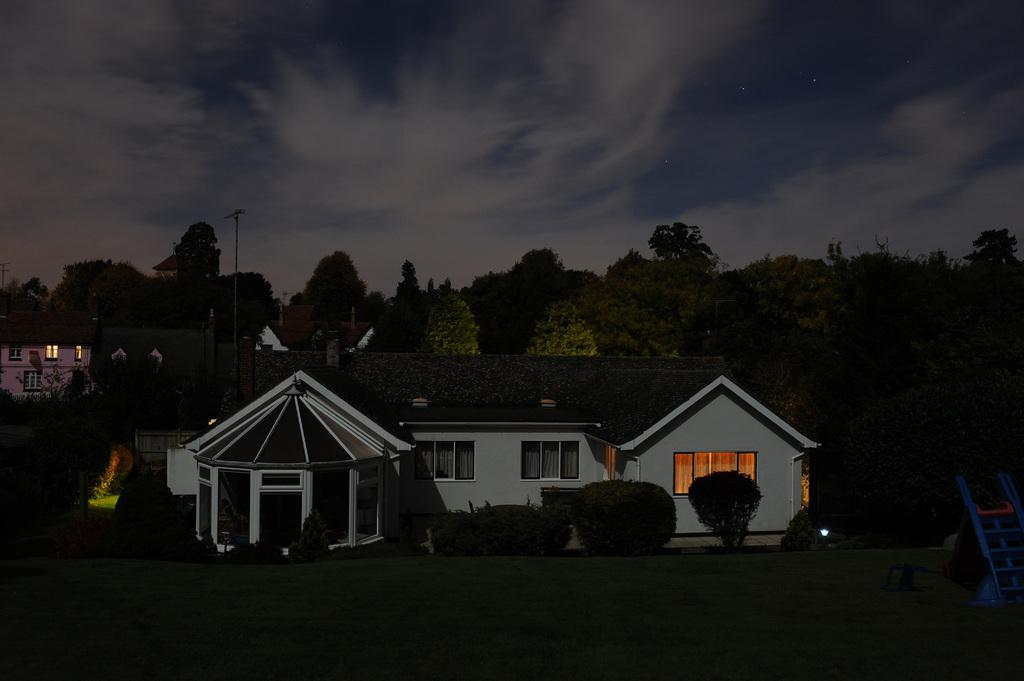What type of structures can be seen in the image? There are buildings in the image. What other natural elements are present in the image? There are trees in the image. Can you describe the object on the grassland on the right side of the image? Unfortunately, the facts provided do not give enough information to describe the object on the grassland. Where is the pole located in the image? The pole is on the left side of the image. What is visible at the top of the image? The sky is visible at the top of the image. What can be seen in the sky? There are clouds in the sky. What type of trousers is the hope wearing in the image? There is no mention of hope or trousers in the image, as the facts provided only describe the presence of buildings, trees, an object on the grassland, a pole, the sky, and clouds. 